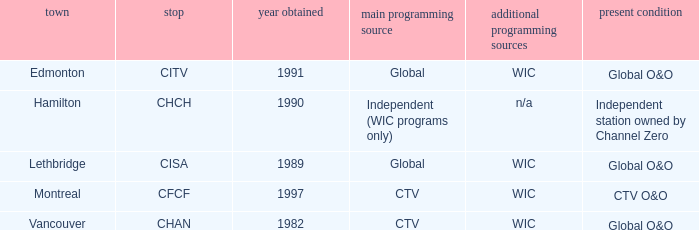Parse the table in full. {'header': ['town', 'stop', 'year obtained', 'main programming source', 'additional programming sources', 'present condition'], 'rows': [['Edmonton', 'CITV', '1991', 'Global', 'WIC', 'Global O&O'], ['Hamilton', 'CHCH', '1990', 'Independent (WIC programs only)', 'n/a', 'Independent station owned by Channel Zero'], ['Lethbridge', 'CISA', '1989', 'Global', 'WIC', 'Global O&O'], ['Montreal', 'CFCF', '1997', 'CTV', 'WIC', 'CTV O&O'], ['Vancouver', 'CHAN', '1982', 'CTV', 'WIC', 'Global O&O']]} How any were gained as the chan 1.0. 